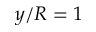<formula> <loc_0><loc_0><loc_500><loc_500>y / R = 1</formula> 